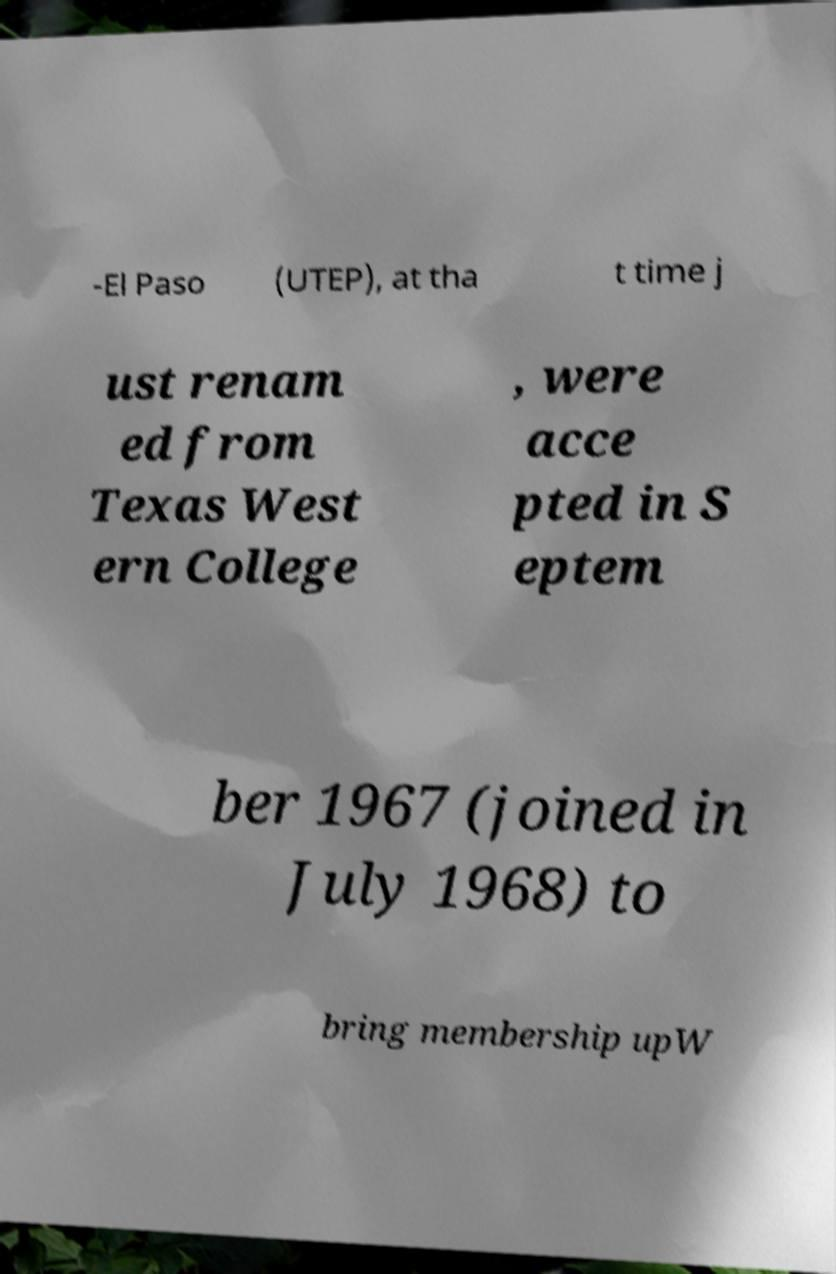Please read and relay the text visible in this image. What does it say? -El Paso (UTEP), at tha t time j ust renam ed from Texas West ern College , were acce pted in S eptem ber 1967 (joined in July 1968) to bring membership upW 